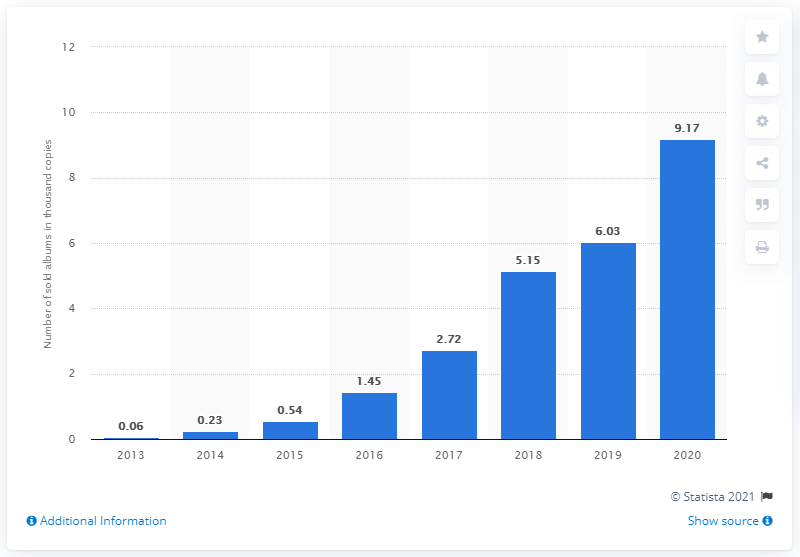Give some essential details in this illustration. The Bangtan Boys have sold a total of 9.17 albums up until 2020. 